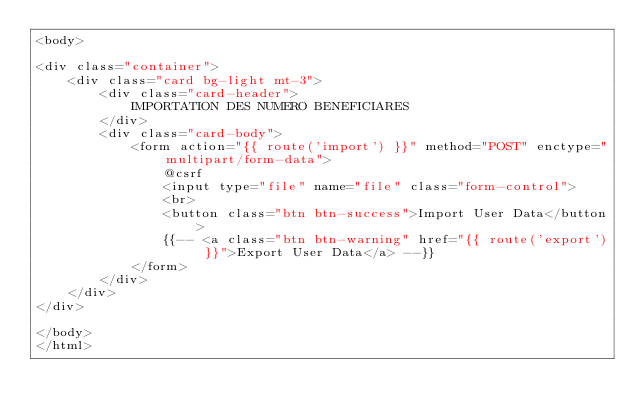Convert code to text. <code><loc_0><loc_0><loc_500><loc_500><_PHP_><body>

<div class="container">
    <div class="card bg-light mt-3">
        <div class="card-header">
            IMPORTATION DES NUMERO BENEFICIARES
        </div>
        <div class="card-body">
            <form action="{{ route('import') }}" method="POST" enctype="multipart/form-data">
                @csrf
                <input type="file" name="file" class="form-control">
                <br>
                <button class="btn btn-success">Import User Data</button>
                {{-- <a class="btn btn-warning" href="{{ route('export') }}">Export User Data</a> --}}
            </form>
        </div>
    </div>
</div>

</body>
</html>
</code> 